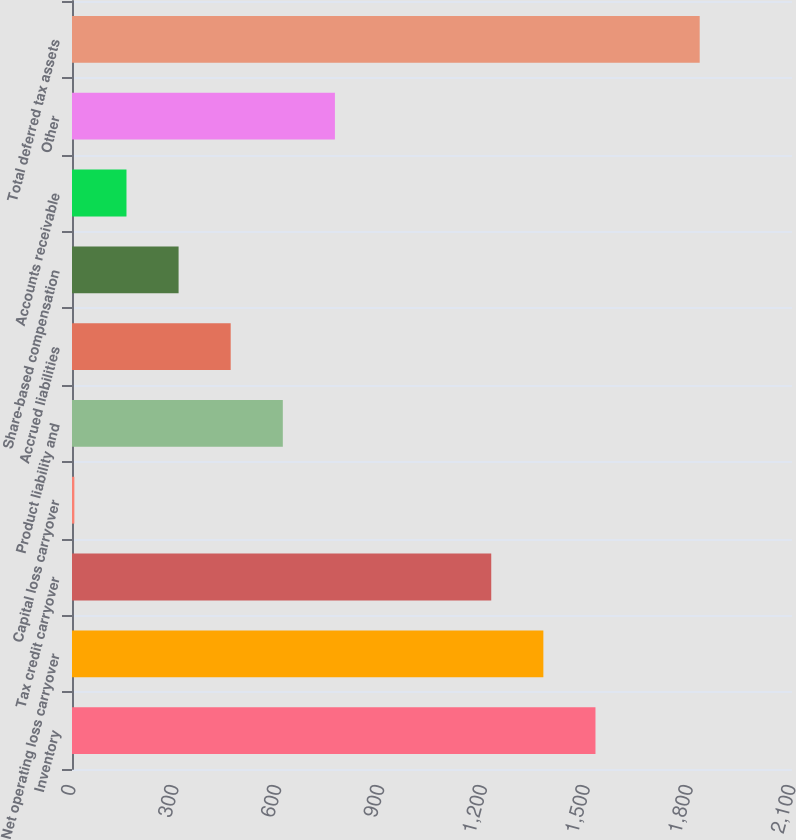Convert chart. <chart><loc_0><loc_0><loc_500><loc_500><bar_chart><fcel>Inventory<fcel>Net operating loss carryover<fcel>Tax credit carryover<fcel>Capital loss carryover<fcel>Product liability and<fcel>Accrued liabilities<fcel>Share-based compensation<fcel>Accounts receivable<fcel>Other<fcel>Total deferred tax assets<nl><fcel>1526.8<fcel>1374.81<fcel>1222.82<fcel>6.9<fcel>614.86<fcel>462.87<fcel>310.88<fcel>158.89<fcel>766.85<fcel>1830.78<nl></chart> 